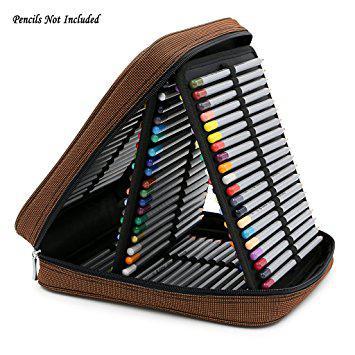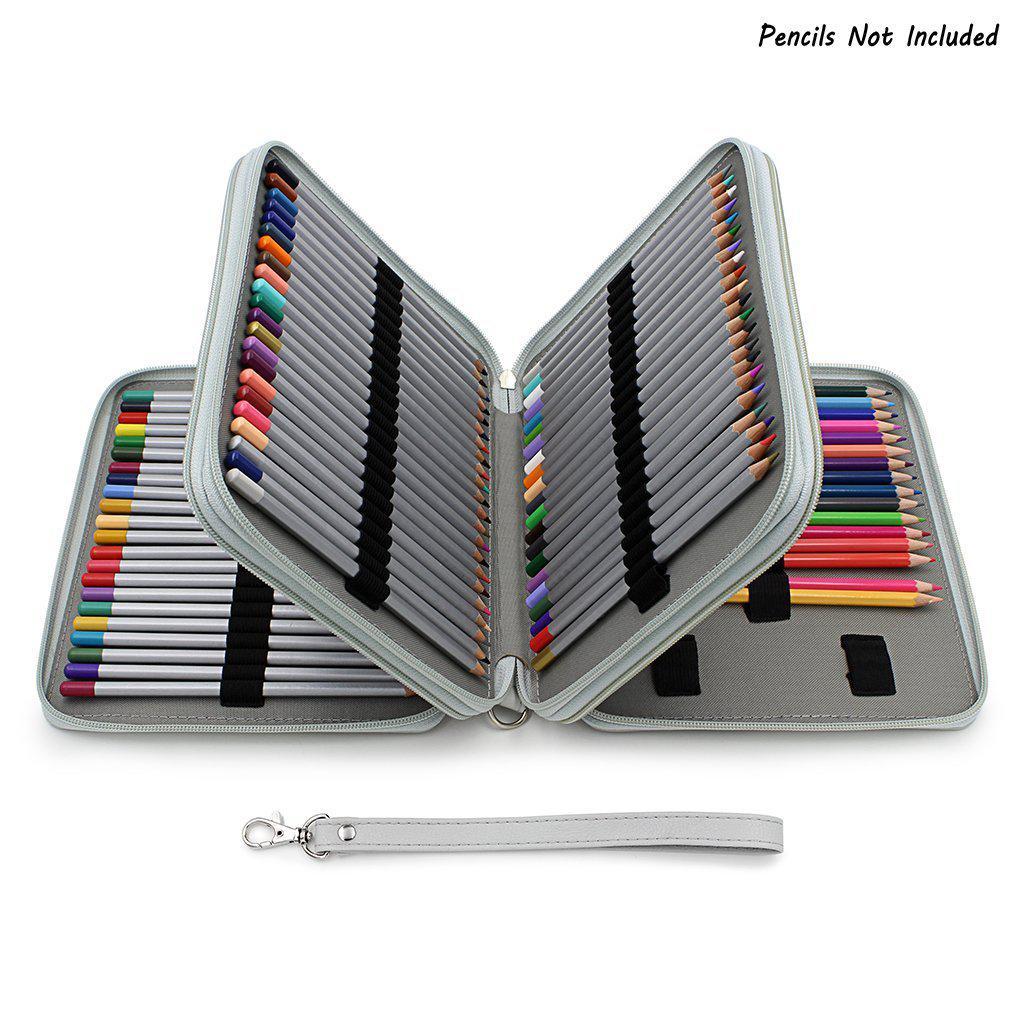The first image is the image on the left, the second image is the image on the right. Examine the images to the left and right. Is the description "One image shows a fold-out pencil case forming a triangle shape and filled with colored-lead pencils." accurate? Answer yes or no. Yes. The first image is the image on the left, the second image is the image on the right. Examine the images to the left and right. Is the description "Some of the pencils are completely out of the case in one of the images." accurate? Answer yes or no. No. 